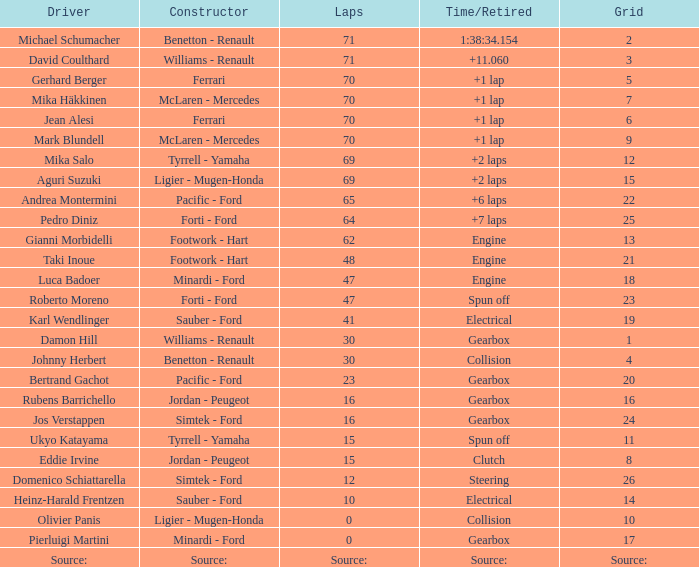How many laps were there in grid 21? 48.0. 